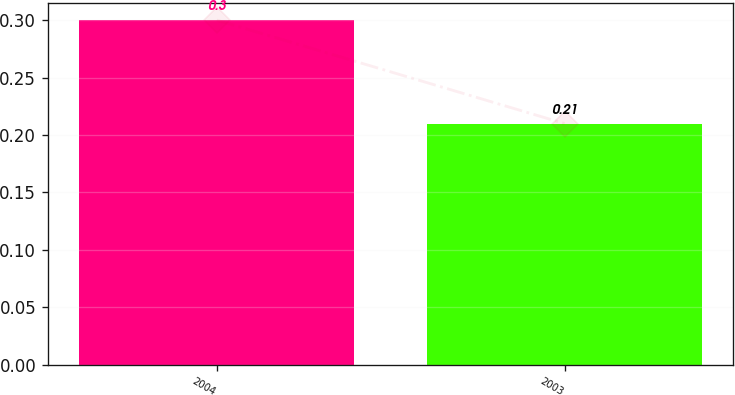Convert chart. <chart><loc_0><loc_0><loc_500><loc_500><bar_chart><fcel>2004<fcel>2003<nl><fcel>0.3<fcel>0.21<nl></chart> 